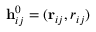<formula> <loc_0><loc_0><loc_500><loc_500>\mathbf h _ { i j } ^ { 0 } = ( \mathbf r _ { i j } , r _ { i j } )</formula> 